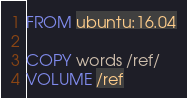Convert code to text. <code><loc_0><loc_0><loc_500><loc_500><_Dockerfile_>FROM ubuntu:16.04

COPY words /ref/
VOLUME /ref
</code> 